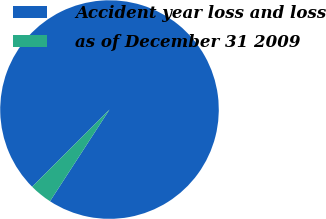<chart> <loc_0><loc_0><loc_500><loc_500><pie_chart><fcel>Accident year loss and loss<fcel>as of December 31 2009<nl><fcel>96.64%<fcel>3.36%<nl></chart> 